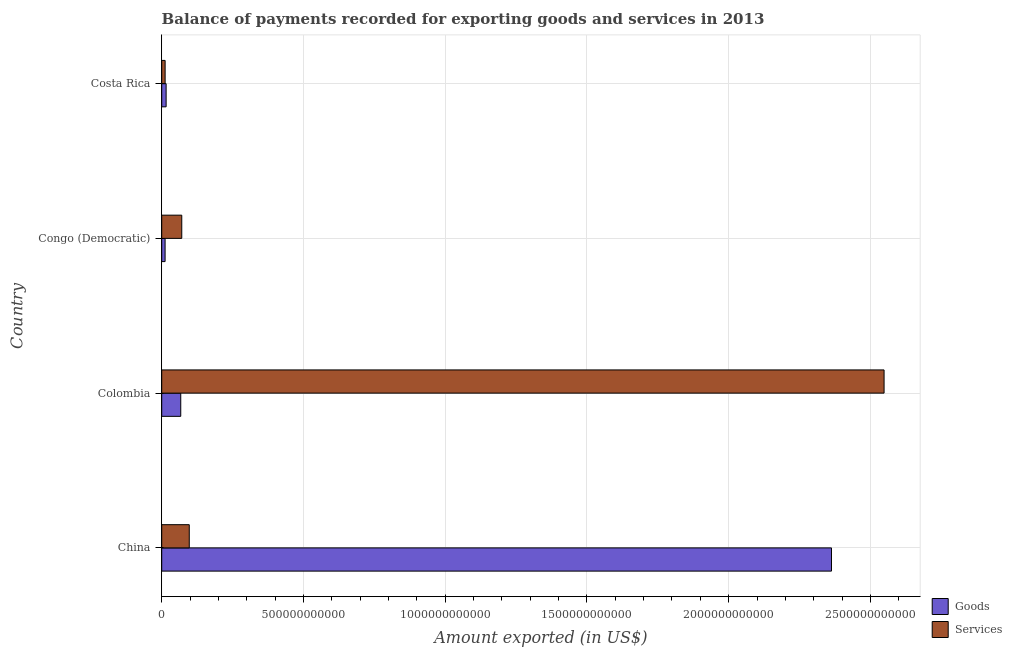How many groups of bars are there?
Your answer should be very brief. 4. Are the number of bars per tick equal to the number of legend labels?
Your answer should be compact. Yes. Are the number of bars on each tick of the Y-axis equal?
Your answer should be compact. Yes. How many bars are there on the 1st tick from the top?
Keep it short and to the point. 2. What is the label of the 1st group of bars from the top?
Your response must be concise. Costa Rica. In how many cases, is the number of bars for a given country not equal to the number of legend labels?
Offer a terse response. 0. What is the amount of goods exported in China?
Provide a succinct answer. 2.36e+12. Across all countries, what is the maximum amount of goods exported?
Your response must be concise. 2.36e+12. Across all countries, what is the minimum amount of services exported?
Keep it short and to the point. 1.21e+1. In which country was the amount of goods exported minimum?
Offer a terse response. Congo (Democratic). What is the total amount of goods exported in the graph?
Provide a short and direct response. 2.46e+12. What is the difference between the amount of services exported in Colombia and that in Costa Rica?
Give a very brief answer. 2.54e+12. What is the difference between the amount of goods exported in China and the amount of services exported in Colombia?
Make the answer very short. -1.86e+11. What is the average amount of services exported per country?
Provide a succinct answer. 6.82e+11. What is the difference between the amount of goods exported and amount of services exported in China?
Make the answer very short. 2.27e+12. What is the ratio of the amount of goods exported in China to that in Congo (Democratic)?
Provide a succinct answer. 198.39. What is the difference between the highest and the second highest amount of services exported?
Provide a short and direct response. 2.45e+12. What is the difference between the highest and the lowest amount of services exported?
Keep it short and to the point. 2.54e+12. What does the 1st bar from the top in Costa Rica represents?
Offer a very short reply. Services. What does the 2nd bar from the bottom in Costa Rica represents?
Ensure brevity in your answer.  Services. How many countries are there in the graph?
Your response must be concise. 4. What is the difference between two consecutive major ticks on the X-axis?
Give a very brief answer. 5.00e+11. Where does the legend appear in the graph?
Keep it short and to the point. Bottom right. How are the legend labels stacked?
Offer a very short reply. Vertical. What is the title of the graph?
Make the answer very short. Balance of payments recorded for exporting goods and services in 2013. Does "Broad money growth" appear as one of the legend labels in the graph?
Your answer should be very brief. No. What is the label or title of the X-axis?
Your response must be concise. Amount exported (in US$). What is the Amount exported (in US$) in Goods in China?
Keep it short and to the point. 2.36e+12. What is the Amount exported (in US$) in Services in China?
Offer a terse response. 9.72e+1. What is the Amount exported (in US$) in Goods in Colombia?
Keep it short and to the point. 6.71e+1. What is the Amount exported (in US$) of Services in Colombia?
Ensure brevity in your answer.  2.55e+12. What is the Amount exported (in US$) in Goods in Congo (Democratic)?
Give a very brief answer. 1.19e+1. What is the Amount exported (in US$) in Services in Congo (Democratic)?
Provide a succinct answer. 7.08e+1. What is the Amount exported (in US$) of Goods in Costa Rica?
Keep it short and to the point. 1.56e+1. What is the Amount exported (in US$) of Services in Costa Rica?
Give a very brief answer. 1.21e+1. Across all countries, what is the maximum Amount exported (in US$) of Goods?
Provide a short and direct response. 2.36e+12. Across all countries, what is the maximum Amount exported (in US$) of Services?
Keep it short and to the point. 2.55e+12. Across all countries, what is the minimum Amount exported (in US$) of Goods?
Your answer should be very brief. 1.19e+1. Across all countries, what is the minimum Amount exported (in US$) in Services?
Your answer should be very brief. 1.21e+1. What is the total Amount exported (in US$) in Goods in the graph?
Offer a terse response. 2.46e+12. What is the total Amount exported (in US$) of Services in the graph?
Ensure brevity in your answer.  2.73e+12. What is the difference between the Amount exported (in US$) in Goods in China and that in Colombia?
Provide a succinct answer. 2.30e+12. What is the difference between the Amount exported (in US$) in Services in China and that in Colombia?
Offer a very short reply. -2.45e+12. What is the difference between the Amount exported (in US$) of Goods in China and that in Congo (Democratic)?
Offer a terse response. 2.35e+12. What is the difference between the Amount exported (in US$) in Services in China and that in Congo (Democratic)?
Offer a terse response. 2.65e+1. What is the difference between the Amount exported (in US$) of Goods in China and that in Costa Rica?
Offer a terse response. 2.35e+12. What is the difference between the Amount exported (in US$) in Services in China and that in Costa Rica?
Your answer should be compact. 8.52e+1. What is the difference between the Amount exported (in US$) in Goods in Colombia and that in Congo (Democratic)?
Offer a terse response. 5.52e+1. What is the difference between the Amount exported (in US$) of Services in Colombia and that in Congo (Democratic)?
Provide a succinct answer. 2.48e+12. What is the difference between the Amount exported (in US$) of Goods in Colombia and that in Costa Rica?
Make the answer very short. 5.16e+1. What is the difference between the Amount exported (in US$) in Services in Colombia and that in Costa Rica?
Provide a succinct answer. 2.54e+12. What is the difference between the Amount exported (in US$) in Goods in Congo (Democratic) and that in Costa Rica?
Ensure brevity in your answer.  -3.66e+09. What is the difference between the Amount exported (in US$) in Services in Congo (Democratic) and that in Costa Rica?
Offer a terse response. 5.87e+1. What is the difference between the Amount exported (in US$) in Goods in China and the Amount exported (in US$) in Services in Colombia?
Offer a very short reply. -1.86e+11. What is the difference between the Amount exported (in US$) in Goods in China and the Amount exported (in US$) in Services in Congo (Democratic)?
Ensure brevity in your answer.  2.29e+12. What is the difference between the Amount exported (in US$) of Goods in China and the Amount exported (in US$) of Services in Costa Rica?
Offer a very short reply. 2.35e+12. What is the difference between the Amount exported (in US$) in Goods in Colombia and the Amount exported (in US$) in Services in Congo (Democratic)?
Your answer should be compact. -3.61e+09. What is the difference between the Amount exported (in US$) in Goods in Colombia and the Amount exported (in US$) in Services in Costa Rica?
Your answer should be very brief. 5.51e+1. What is the difference between the Amount exported (in US$) of Goods in Congo (Democratic) and the Amount exported (in US$) of Services in Costa Rica?
Give a very brief answer. -1.45e+08. What is the average Amount exported (in US$) in Goods per country?
Your answer should be very brief. 6.14e+11. What is the average Amount exported (in US$) of Services per country?
Offer a very short reply. 6.82e+11. What is the difference between the Amount exported (in US$) of Goods and Amount exported (in US$) of Services in China?
Offer a very short reply. 2.27e+12. What is the difference between the Amount exported (in US$) in Goods and Amount exported (in US$) in Services in Colombia?
Offer a terse response. -2.48e+12. What is the difference between the Amount exported (in US$) of Goods and Amount exported (in US$) of Services in Congo (Democratic)?
Provide a short and direct response. -5.88e+1. What is the difference between the Amount exported (in US$) in Goods and Amount exported (in US$) in Services in Costa Rica?
Give a very brief answer. 3.52e+09. What is the ratio of the Amount exported (in US$) in Goods in China to that in Colombia?
Offer a very short reply. 35.19. What is the ratio of the Amount exported (in US$) of Services in China to that in Colombia?
Provide a succinct answer. 0.04. What is the ratio of the Amount exported (in US$) of Goods in China to that in Congo (Democratic)?
Your answer should be very brief. 198.39. What is the ratio of the Amount exported (in US$) of Services in China to that in Congo (Democratic)?
Provide a succinct answer. 1.37. What is the ratio of the Amount exported (in US$) of Goods in China to that in Costa Rica?
Your response must be concise. 151.73. What is the ratio of the Amount exported (in US$) in Services in China to that in Costa Rica?
Offer a very short reply. 8.07. What is the ratio of the Amount exported (in US$) in Goods in Colombia to that in Congo (Democratic)?
Provide a short and direct response. 5.64. What is the ratio of the Amount exported (in US$) of Services in Colombia to that in Congo (Democratic)?
Make the answer very short. 36.01. What is the ratio of the Amount exported (in US$) in Goods in Colombia to that in Costa Rica?
Keep it short and to the point. 4.31. What is the ratio of the Amount exported (in US$) of Services in Colombia to that in Costa Rica?
Your response must be concise. 211.4. What is the ratio of the Amount exported (in US$) in Goods in Congo (Democratic) to that in Costa Rica?
Give a very brief answer. 0.76. What is the ratio of the Amount exported (in US$) in Services in Congo (Democratic) to that in Costa Rica?
Provide a short and direct response. 5.87. What is the difference between the highest and the second highest Amount exported (in US$) in Goods?
Provide a succinct answer. 2.30e+12. What is the difference between the highest and the second highest Amount exported (in US$) of Services?
Offer a terse response. 2.45e+12. What is the difference between the highest and the lowest Amount exported (in US$) of Goods?
Ensure brevity in your answer.  2.35e+12. What is the difference between the highest and the lowest Amount exported (in US$) in Services?
Offer a very short reply. 2.54e+12. 